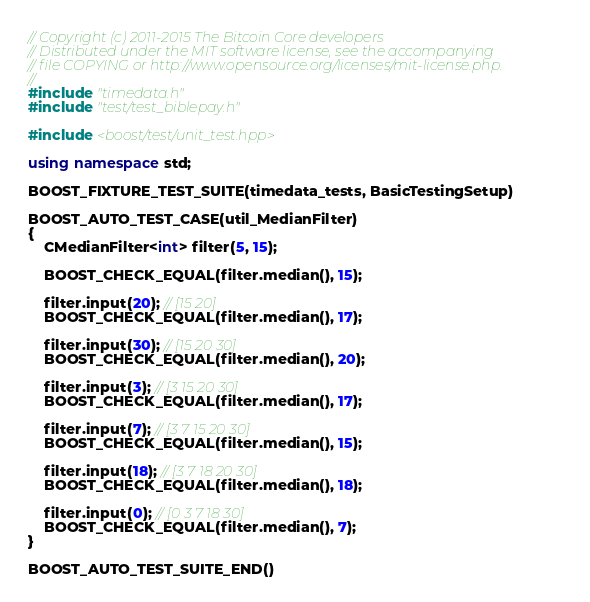Convert code to text. <code><loc_0><loc_0><loc_500><loc_500><_C++_>// Copyright (c) 2011-2015 The Bitcoin Core developers
// Distributed under the MIT software license, see the accompanying
// file COPYING or http://www.opensource.org/licenses/mit-license.php.
//
#include "timedata.h"
#include "test/test_biblepay.h"

#include <boost/test/unit_test.hpp>

using namespace std;

BOOST_FIXTURE_TEST_SUITE(timedata_tests, BasicTestingSetup)

BOOST_AUTO_TEST_CASE(util_MedianFilter)
{
    CMedianFilter<int> filter(5, 15);

    BOOST_CHECK_EQUAL(filter.median(), 15);

    filter.input(20); // [15 20]
    BOOST_CHECK_EQUAL(filter.median(), 17);

    filter.input(30); // [15 20 30]
    BOOST_CHECK_EQUAL(filter.median(), 20);

    filter.input(3); // [3 15 20 30]
    BOOST_CHECK_EQUAL(filter.median(), 17);

    filter.input(7); // [3 7 15 20 30]
    BOOST_CHECK_EQUAL(filter.median(), 15);

    filter.input(18); // [3 7 18 20 30]
    BOOST_CHECK_EQUAL(filter.median(), 18);

    filter.input(0); // [0 3 7 18 30]
    BOOST_CHECK_EQUAL(filter.median(), 7);
}

BOOST_AUTO_TEST_SUITE_END()
</code> 